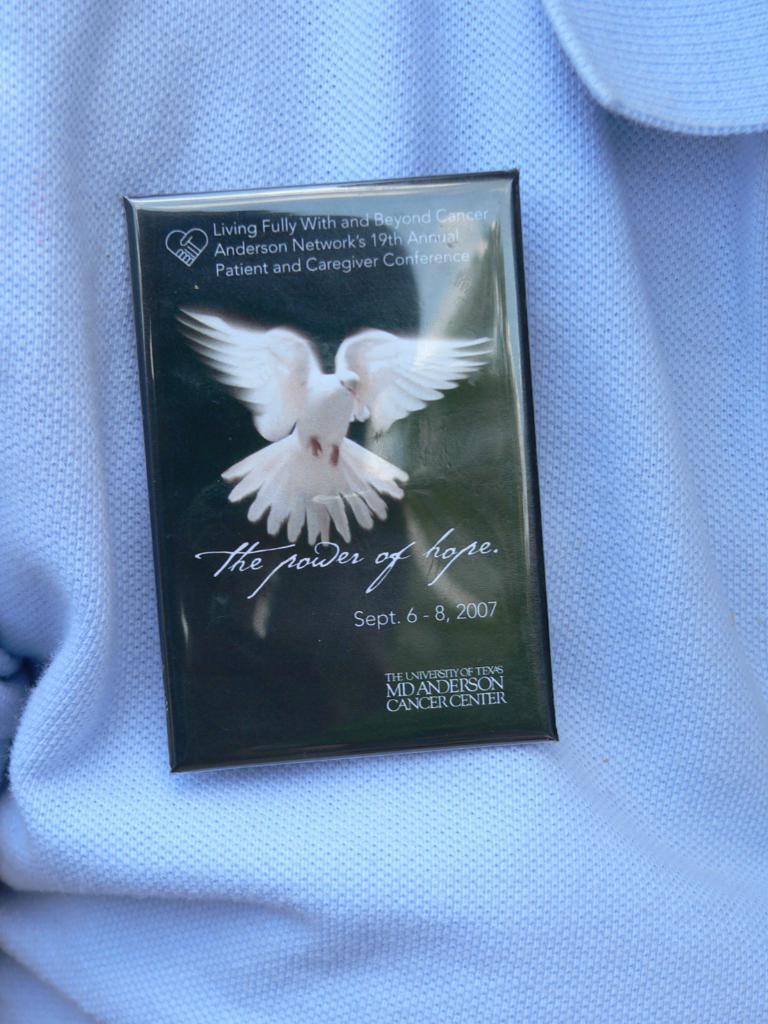Please provide a concise description of this image. In this image there is a T-shirt which is white in color and in the middle of the image there is a card with an image of a bird and there is a text on it. 